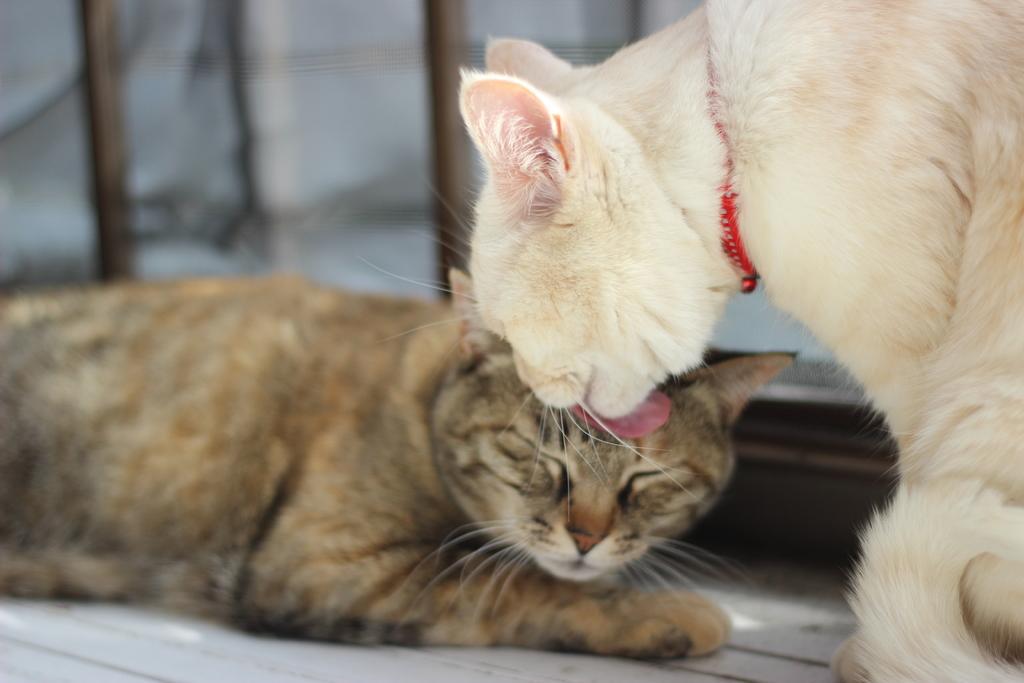Please provide a concise description of this image. In this picture I can see there are two cats a brown and a white on right side and there is a wall in the backdrop. 